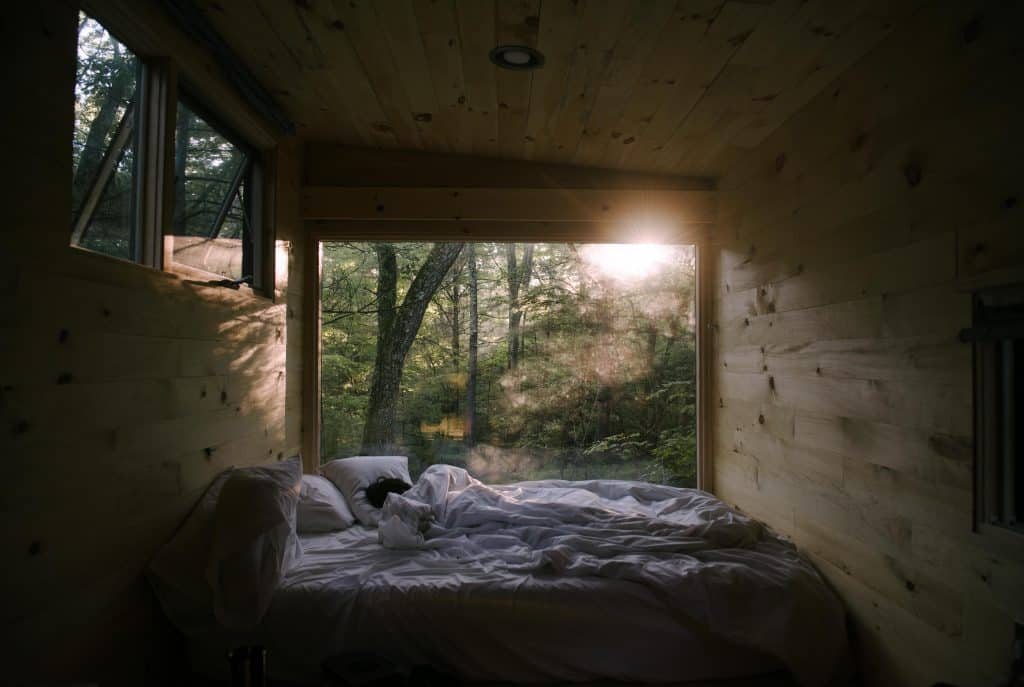Considering the materials and construction visible in the image, what style or philosophy might have influenced this bedroom's design? The use of natural wood for the walls and the simple, sturdy construction suggest a design philosophy rooted in rustic minimalism and perhaps Scandinavian influences. This aesthetic values functionality and simplicity, quietly harmonizing with the natural environment through organic materials and understated elegance. The design aims for sustainability, warmth, and a soothing sensory experience, emphasizing a connection to nature with a reduced environmental impact. 